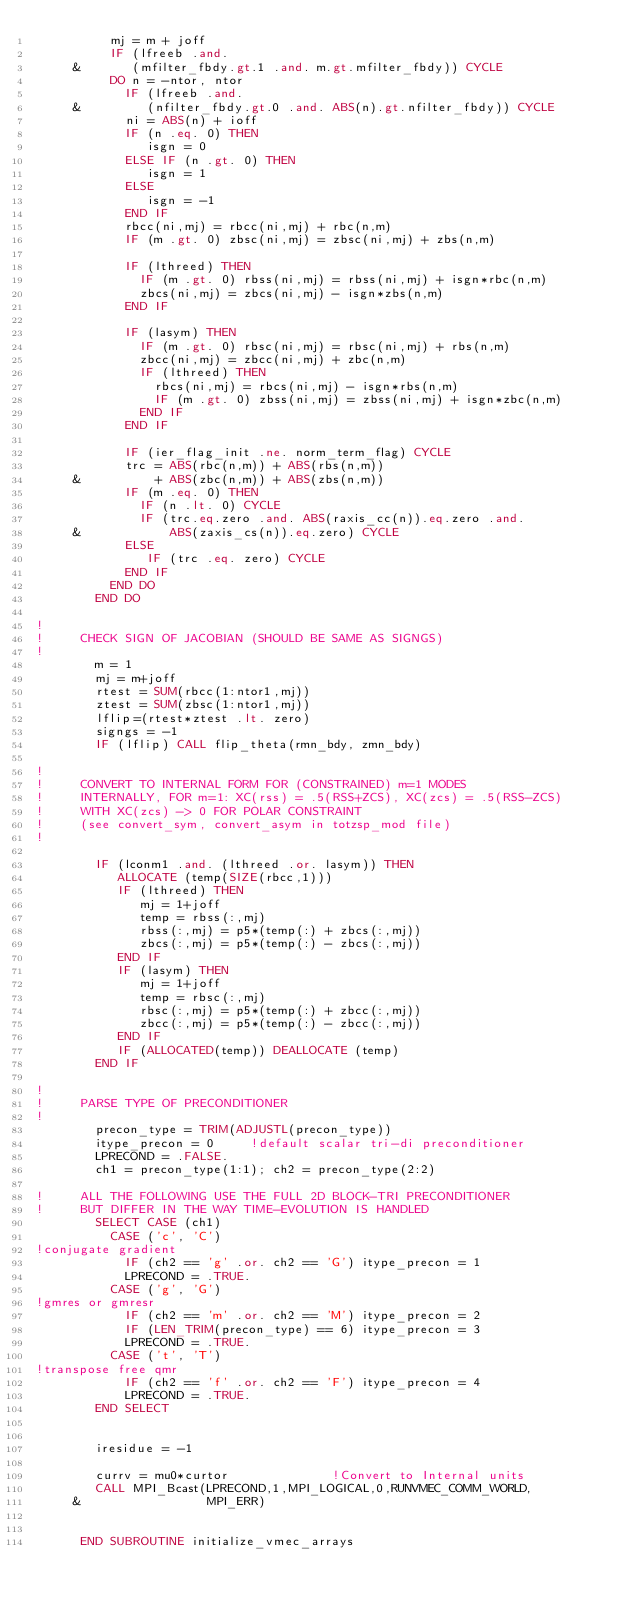<code> <loc_0><loc_0><loc_500><loc_500><_FORTRAN_>          mj = m + joff
          IF (lfreeb .and. 
     &       (mfilter_fbdy.gt.1 .and. m.gt.mfilter_fbdy)) CYCLE
          DO n = -ntor, ntor
            IF (lfreeb .and. 
     &         (nfilter_fbdy.gt.0 .and. ABS(n).gt.nfilter_fbdy)) CYCLE
            ni = ABS(n) + ioff
            IF (n .eq. 0) THEN
               isgn = 0
            ELSE IF (n .gt. 0) THEN
               isgn = 1
            ELSE
               isgn = -1
            END IF
            rbcc(ni,mj) = rbcc(ni,mj) + rbc(n,m)
            IF (m .gt. 0) zbsc(ni,mj) = zbsc(ni,mj) + zbs(n,m)

            IF (lthreed) THEN
              IF (m .gt. 0) rbss(ni,mj) = rbss(ni,mj) + isgn*rbc(n,m)
              zbcs(ni,mj) = zbcs(ni,mj) - isgn*zbs(n,m)
            END IF

            IF (lasym) THEN
              IF (m .gt. 0) rbsc(ni,mj) = rbsc(ni,mj) + rbs(n,m)
              zbcc(ni,mj) = zbcc(ni,mj) + zbc(n,m)
              IF (lthreed) THEN
                rbcs(ni,mj) = rbcs(ni,mj) - isgn*rbs(n,m)
                IF (m .gt. 0) zbss(ni,mj) = zbss(ni,mj) + isgn*zbc(n,m)
              END IF
            END IF

            IF (ier_flag_init .ne. norm_term_flag) CYCLE
            trc = ABS(rbc(n,m)) + ABS(rbs(n,m))
     &          + ABS(zbc(n,m)) + ABS(zbs(n,m))
            IF (m .eq. 0) THEN
              IF (n .lt. 0) CYCLE
              IF (trc.eq.zero .and. ABS(raxis_cc(n)).eq.zero .and.
     &            ABS(zaxis_cs(n)).eq.zero) CYCLE
            ELSE
               IF (trc .eq. zero) CYCLE
            END IF
          END DO
        END DO

!
!     CHECK SIGN OF JACOBIAN (SHOULD BE SAME AS SIGNGS)
!
        m = 1
        mj = m+joff
        rtest = SUM(rbcc(1:ntor1,mj))
        ztest = SUM(zbsc(1:ntor1,mj))
        lflip=(rtest*ztest .lt. zero)
        signgs = -1
        IF (lflip) CALL flip_theta(rmn_bdy, zmn_bdy)

!
!     CONVERT TO INTERNAL FORM FOR (CONSTRAINED) m=1 MODES
!     INTERNALLY, FOR m=1: XC(rss) = .5(RSS+ZCS), XC(zcs) = .5(RSS-ZCS)
!     WITH XC(zcs) -> 0 FOR POLAR CONSTRAINT 
!     (see convert_sym, convert_asym in totzsp_mod file)
!

        IF (lconm1 .and. (lthreed .or. lasym)) THEN
           ALLOCATE (temp(SIZE(rbcc,1)))
           IF (lthreed) THEN
              mj = 1+joff
              temp = rbss(:,mj)
              rbss(:,mj) = p5*(temp(:) + zbcs(:,mj))
              zbcs(:,mj) = p5*(temp(:) - zbcs(:,mj))
           END IF
           IF (lasym) THEN
              mj = 1+joff
              temp = rbsc(:,mj)
              rbsc(:,mj) = p5*(temp(:) + zbcc(:,mj))
              zbcc(:,mj) = p5*(temp(:) - zbcc(:,mj))
           END IF
           IF (ALLOCATED(temp)) DEALLOCATE (temp)
        END IF
      
!
!     PARSE TYPE OF PRECONDITIONER
!
        precon_type = TRIM(ADJUSTL(precon_type))
        itype_precon = 0     !default scalar tri-di preconditioner
        LPRECOND = .FALSE.
        ch1 = precon_type(1:1); ch2 = precon_type(2:2)

!     ALL THE FOLLOWING USE THE FULL 2D BLOCK-TRI PRECONDITIONER
!     BUT DIFFER IN THE WAY TIME-EVOLUTION IS HANDLED
        SELECT CASE (ch1) 
          CASE ('c', 'C')
!conjugate gradient
            IF (ch2 == 'g' .or. ch2 == 'G') itype_precon = 1
            LPRECOND = .TRUE.
          CASE ('g', 'G')
!gmres or gmresr
            IF (ch2 == 'm' .or. ch2 == 'M') itype_precon = 2
            IF (LEN_TRIM(precon_type) == 6) itype_precon = 3
            LPRECOND = .TRUE.
          CASE ('t', 'T')
!transpose free qmr
            IF (ch2 == 'f' .or. ch2 == 'F') itype_precon = 4
            LPRECOND = .TRUE.
        END SELECT
      

        iresidue = -1

        currv = mu0*curtor              !Convert to Internal units
        CALL MPI_Bcast(LPRECOND,1,MPI_LOGICAL,0,RUNVMEC_COMM_WORLD,
     &                 MPI_ERR)


      END SUBROUTINE initialize_vmec_arrays
</code> 